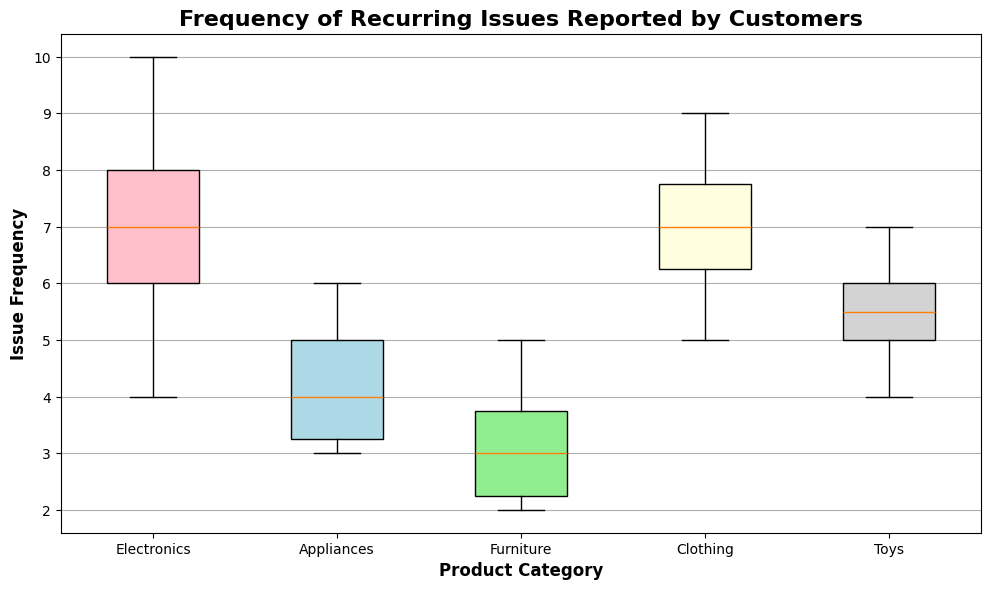Which product category has the highest median frequency of recurring issues? To find the product category with the highest median frequency, look at the middle value of each box in the box plot. The box for Electronics has the highest median line compared to Appliances, Furniture, Clothing, and Toys.
Answer: Electronics What is the range of issue frequency in the Clothing category? The range can be found by looking at the distance between the lower and upper whiskers of the box plot for Clothing. The lower whisker indicates the minimum value (5) and the upper whisker indicates the maximum value (9). So, the range is 9 - 5.
Answer: 4 Which product category shows the least variation in issue frequency? To determine the category with the least variation, look for the box plot with the smallest interquartile range (IQR), which is the width of the box. The Furniture category has the smallest box, indicating the least variation.
Answer: Furniture How does the median issue frequency of Toys compare to that of Appliances? Compare the median lines within the boxes of the Toys and Appliances categories. The median line for Toys is higher than the median line for Appliances.
Answer: Higher What is the interquartile range (IQR) for the Electronics category? Calculate the IQR by subtracting the lower quartile (Q1) from the upper quartile (Q3) for the Electronics category. These quartiles correspond to the bottom and top borders of the box. Suppose Q1 is 6 and Q3 is 8. The IQR is 8 - 6.
Answer: 2 Which product category has the lowest maximum issue frequency? Look at the upper whiskers of all categories to determine the maximum values. The Furniture category has the lowest maximum value, which is 5.
Answer: Furniture What is the median issue frequency for the Appliances category? The median frequency is the value at the centerline of the box in the Appliances category. This line indicates the median, which is around 4.
Answer: 4 Between Clothing and Electronics, which category shows a wider spread of issue frequencies? To determine which category has a wider spread, compare the total length from the bottom whisker to the top whisker in both categories. Electronics has a wider spread from 4 to 10, compared to Clothing's spread from 5 to 9.
Answer: Electronics 